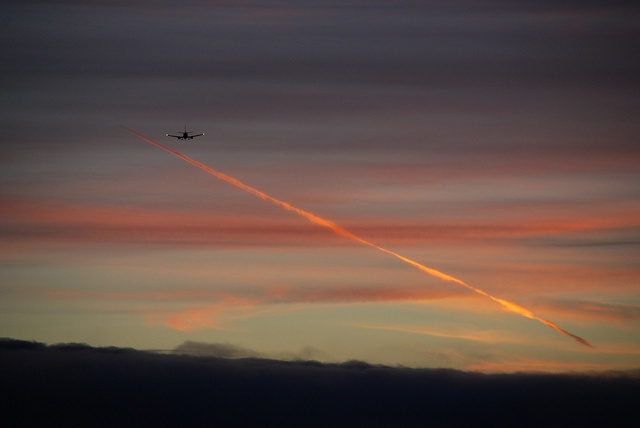Describe the objects in this image and their specific colors. I can see a airplane in black and gray tones in this image. 